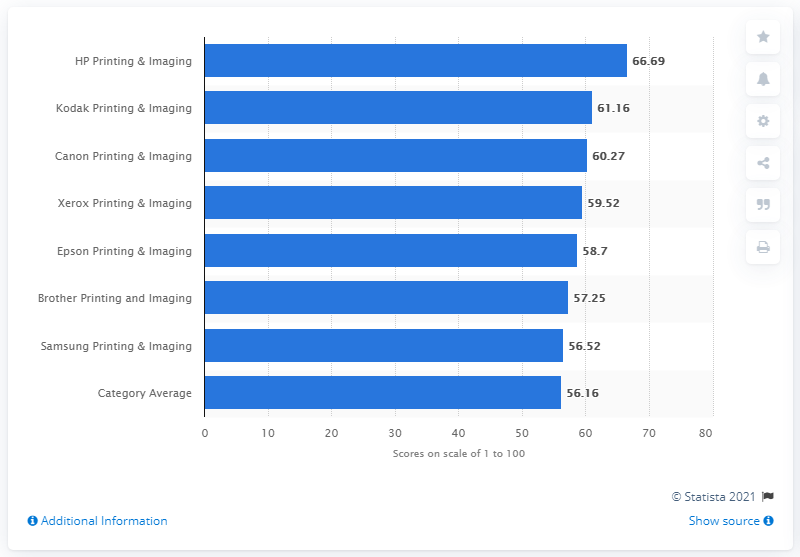Indicate a few pertinent items in this graphic. HP Printing & Imaging received a score of 66.69 out of 100. 